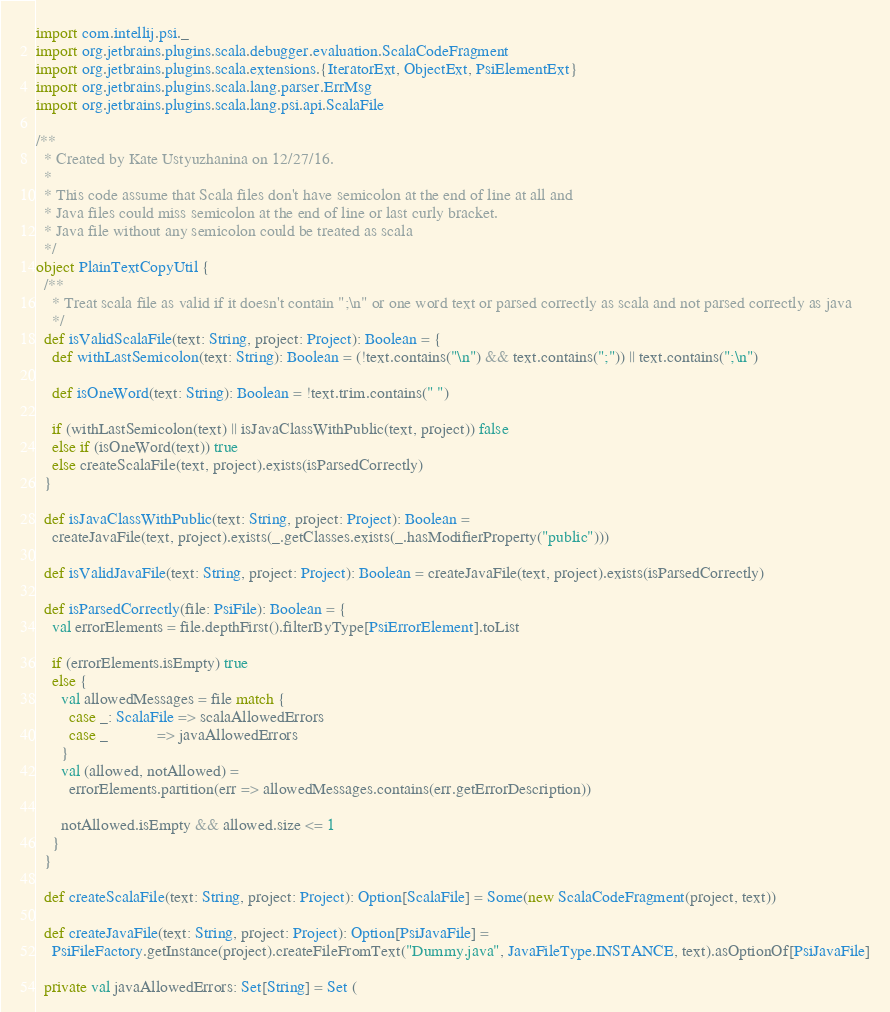Convert code to text. <code><loc_0><loc_0><loc_500><loc_500><_Scala_>import com.intellij.psi._
import org.jetbrains.plugins.scala.debugger.evaluation.ScalaCodeFragment
import org.jetbrains.plugins.scala.extensions.{IteratorExt, ObjectExt, PsiElementExt}
import org.jetbrains.plugins.scala.lang.parser.ErrMsg
import org.jetbrains.plugins.scala.lang.psi.api.ScalaFile

/**
  * Created by Kate Ustyuzhanina on 12/27/16.
  *
  * This code assume that Scala files don't have semicolon at the end of line at all and
  * Java files could miss semicolon at the end of line or last curly bracket.
  * Java file without any semicolon could be treated as scala
  */
object PlainTextCopyUtil {
  /**
    * Treat scala file as valid if it doesn't contain ";\n" or one word text or parsed correctly as scala and not parsed correctly as java
    */
  def isValidScalaFile(text: String, project: Project): Boolean = {
    def withLastSemicolon(text: String): Boolean = (!text.contains("\n") && text.contains(";")) || text.contains(";\n")

    def isOneWord(text: String): Boolean = !text.trim.contains(" ")

    if (withLastSemicolon(text) || isJavaClassWithPublic(text, project)) false
    else if (isOneWord(text)) true
    else createScalaFile(text, project).exists(isParsedCorrectly)
  }

  def isJavaClassWithPublic(text: String, project: Project): Boolean =
    createJavaFile(text, project).exists(_.getClasses.exists(_.hasModifierProperty("public")))

  def isValidJavaFile(text: String, project: Project): Boolean = createJavaFile(text, project).exists(isParsedCorrectly)

  def isParsedCorrectly(file: PsiFile): Boolean = {
    val errorElements = file.depthFirst().filterByType[PsiErrorElement].toList

    if (errorElements.isEmpty) true
    else {
      val allowedMessages = file match {
        case _: ScalaFile => scalaAllowedErrors
        case _            => javaAllowedErrors
      }
      val (allowed, notAllowed) =
        errorElements.partition(err => allowedMessages.contains(err.getErrorDescription))

      notAllowed.isEmpty && allowed.size <= 1
    }
  }

  def createScalaFile(text: String, project: Project): Option[ScalaFile] = Some(new ScalaCodeFragment(project, text))

  def createJavaFile(text: String, project: Project): Option[PsiJavaFile] =
    PsiFileFactory.getInstance(project).createFileFromText("Dummy.java", JavaFileType.INSTANCE, text).asOptionOf[PsiJavaFile]

  private val javaAllowedErrors: Set[String] = Set (</code> 